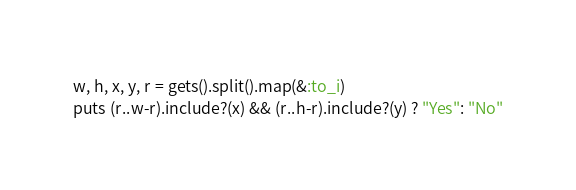Convert code to text. <code><loc_0><loc_0><loc_500><loc_500><_Ruby_>w, h, x, y, r = gets().split().map(&:to_i)
puts (r..w-r).include?(x) && (r..h-r).include?(y) ? "Yes": "No"

</code> 